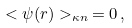<formula> <loc_0><loc_0><loc_500><loc_500>< \psi ( { r } ) > _ { \kappa n } \, = 0 \, ,</formula> 